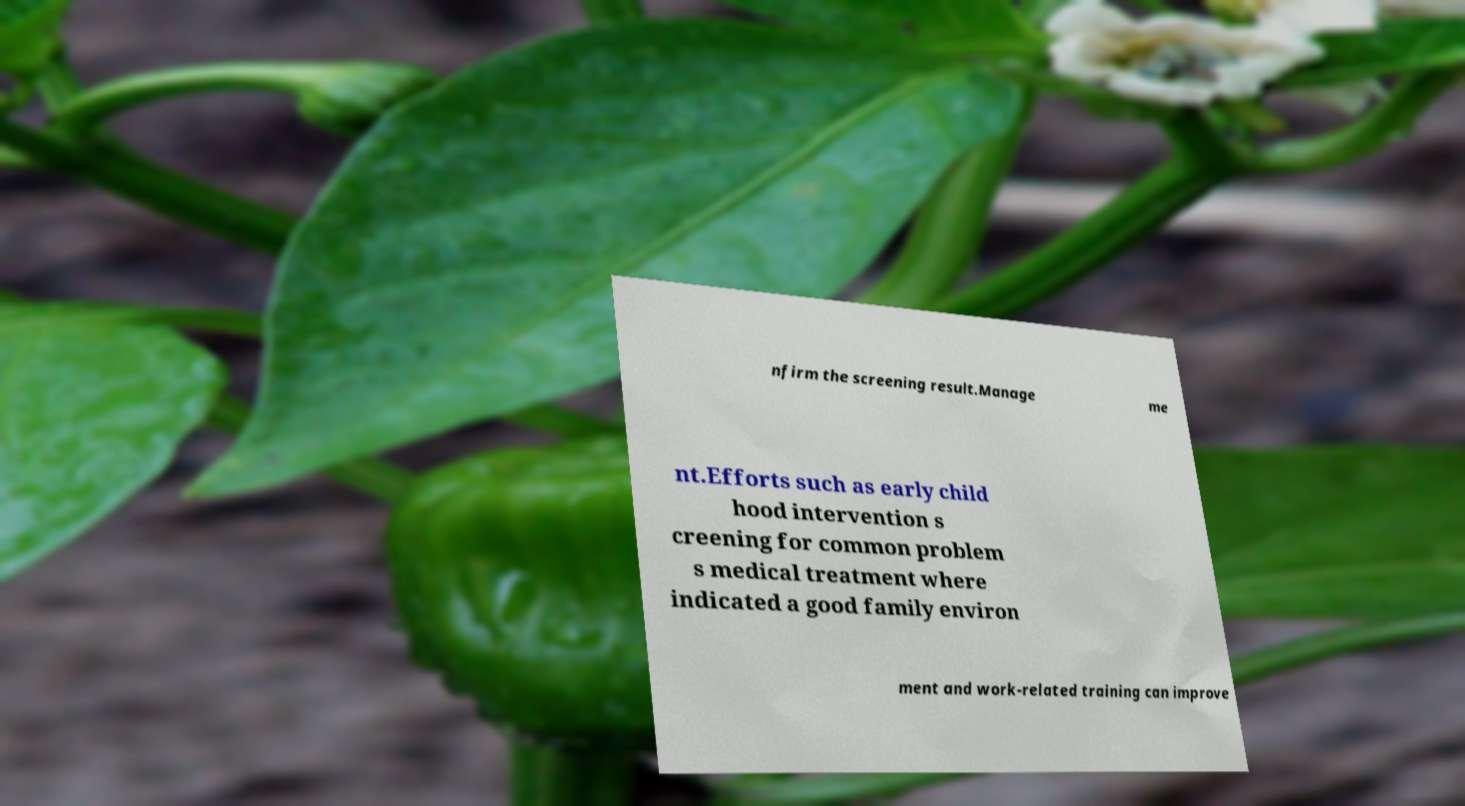What messages or text are displayed in this image? I need them in a readable, typed format. nfirm the screening result.Manage me nt.Efforts such as early child hood intervention s creening for common problem s medical treatment where indicated a good family environ ment and work-related training can improve 